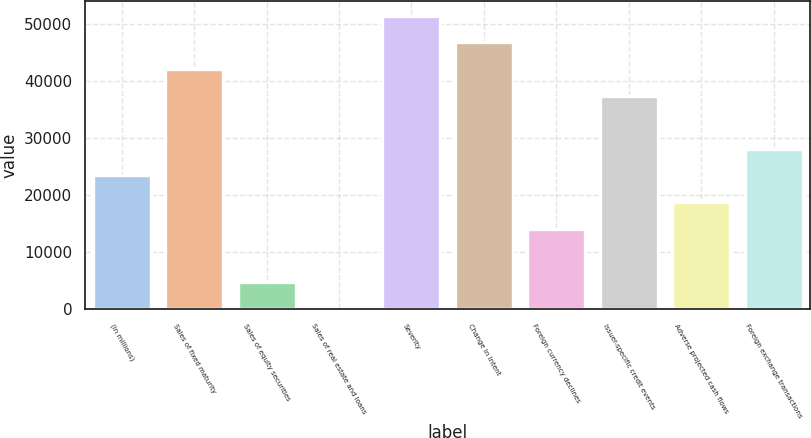Convert chart to OTSL. <chart><loc_0><loc_0><loc_500><loc_500><bar_chart><fcel>(in millions)<fcel>Sales of fixed maturity<fcel>Sales of equity securities<fcel>Sales of real estate and loans<fcel>Severity<fcel>Change in intent<fcel>Foreign currency declines<fcel>Issuer-specific credit events<fcel>Adverse projected cash flows<fcel>Foreign exchange transactions<nl><fcel>23465<fcel>42128.2<fcel>4801.8<fcel>136<fcel>51459.8<fcel>46794<fcel>14133.4<fcel>37462.4<fcel>18799.2<fcel>28130.8<nl></chart> 